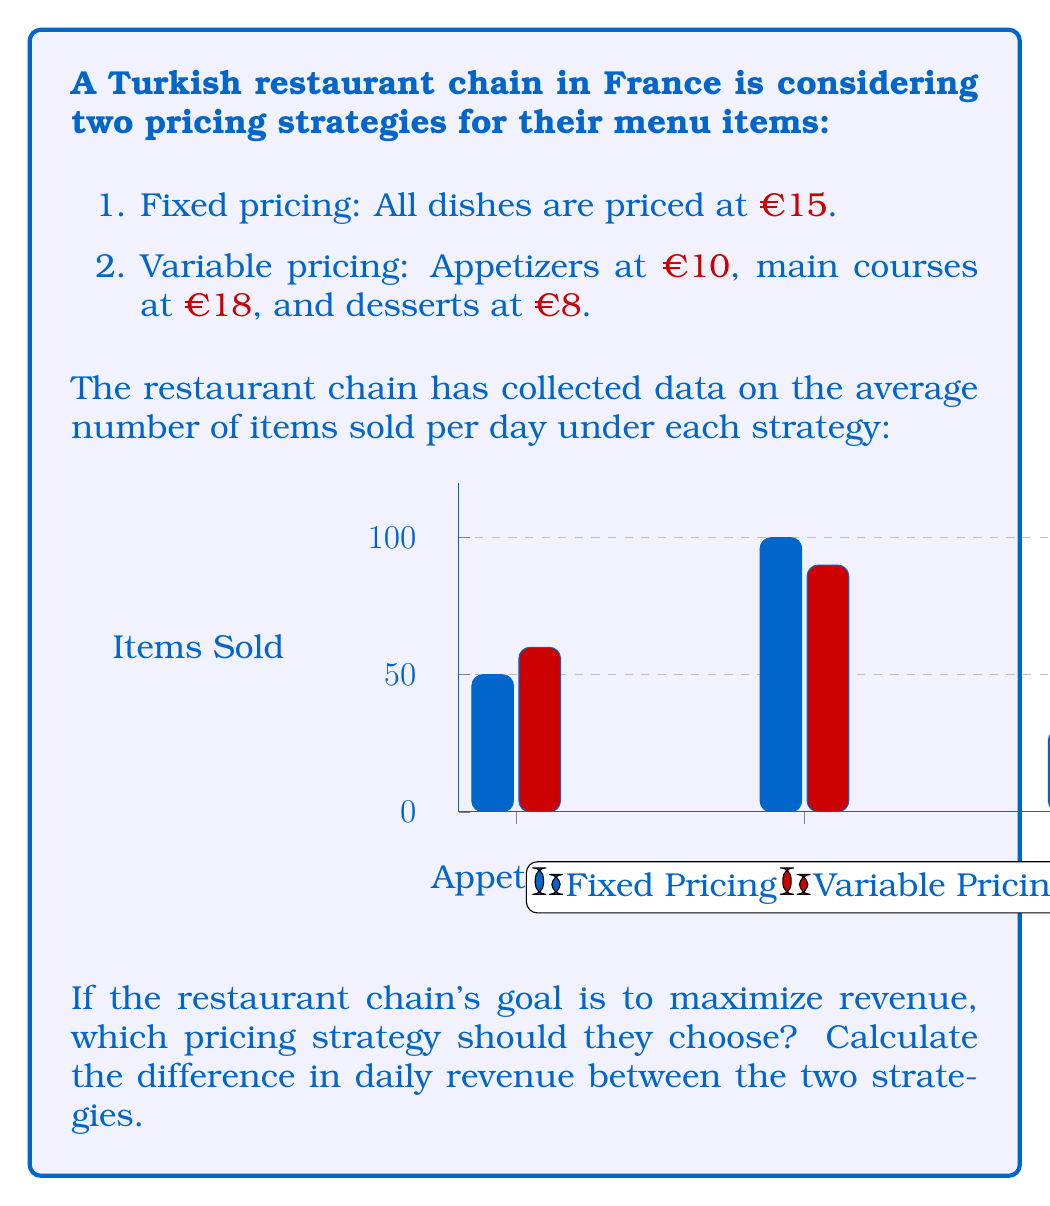Provide a solution to this math problem. Let's approach this problem step-by-step:

1. Calculate the revenue for the fixed pricing strategy:
   - All items are priced at €15
   - Total items sold = 50 + 100 + 30 = 180
   - Revenue = 180 * €15 = €2,700

2. Calculate the revenue for the variable pricing strategy:
   - Appetizers: 60 * €10 = €600
   - Main Courses: 90 * €18 = €1,620
   - Desserts: 40 * €8 = €320
   - Total Revenue = €600 + €1,620 + €320 = €2,540

3. Compare the two strategies:
   - Fixed pricing revenue: €2,700
   - Variable pricing revenue: €2,540
   - Difference: €2,700 - €2,540 = €160

4. Determine the optimal strategy:
   The fixed pricing strategy generates €160 more revenue per day.

Therefore, to maximize revenue, the restaurant chain should choose the fixed pricing strategy.

The difference in daily revenue can be expressed mathematically as:

$$R_f - R_v = (p_f \sum_{i=1}^{n} q_{fi}) - \sum_{i=1}^{n} (p_{vi} q_{vi})$$

Where:
$R_f$ = Revenue from fixed pricing
$R_v$ = Revenue from variable pricing
$p_f$ = Fixed price
$p_{vi}$ = Variable price for item category $i$
$q_{fi}$ = Quantity sold for item category $i$ under fixed pricing
$q_{vi}$ = Quantity sold for item category $i$ under variable pricing
$n$ = Number of item categories

Plugging in the values:

$$(15 * (50 + 100 + 30)) - ((10 * 60) + (18 * 90) + (8 * 40)) = 2700 - 2540 = 160$$
Answer: Fixed pricing; €160 more daily revenue 